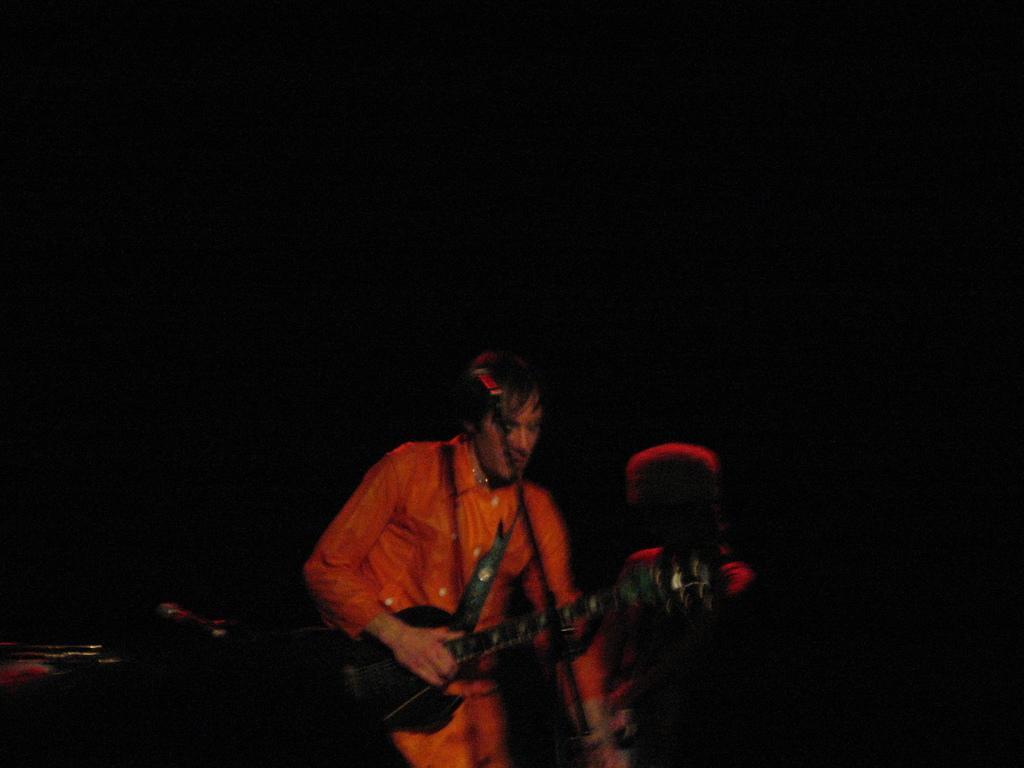Please provide a concise description of this image. At the bottom of this image, there is a person in an orange color shirt, holding a guitar and standing. And the background is dark in color. 